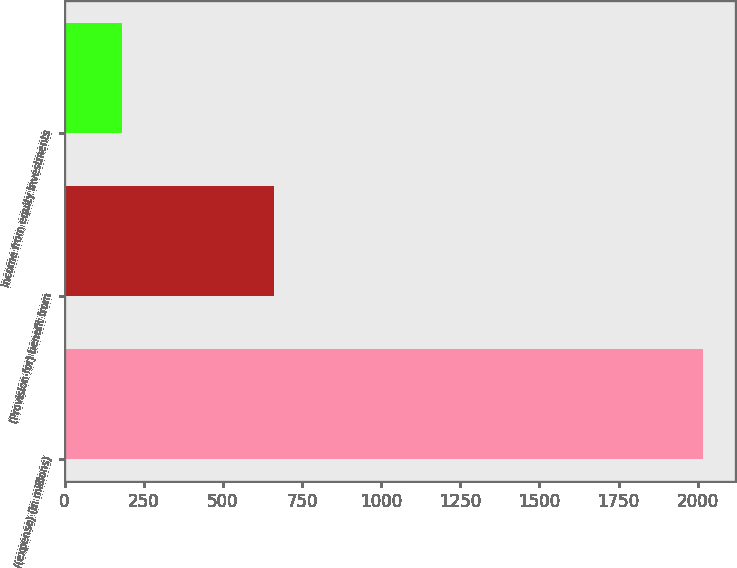Convert chart. <chart><loc_0><loc_0><loc_500><loc_500><bar_chart><fcel>Income/(expense) (in millions)<fcel>(Provision for) benefit from<fcel>Income from equity investments<nl><fcel>2016<fcel>662<fcel>181<nl></chart> 